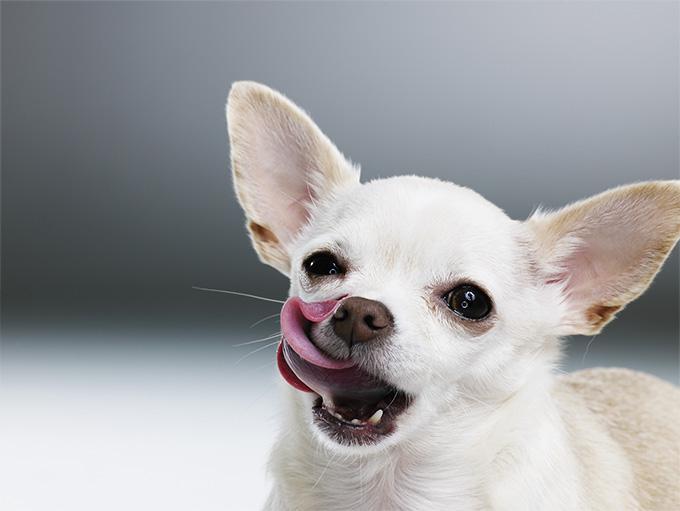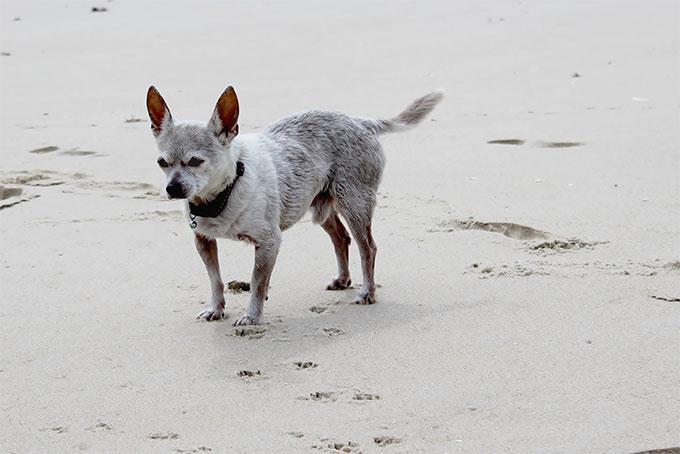The first image is the image on the left, the second image is the image on the right. Considering the images on both sides, is "There are two chihuahuas." valid? Answer yes or no. Yes. The first image is the image on the left, the second image is the image on the right. Evaluate the accuracy of this statement regarding the images: "Each image contains exactly one small dog.". Is it true? Answer yes or no. Yes. 